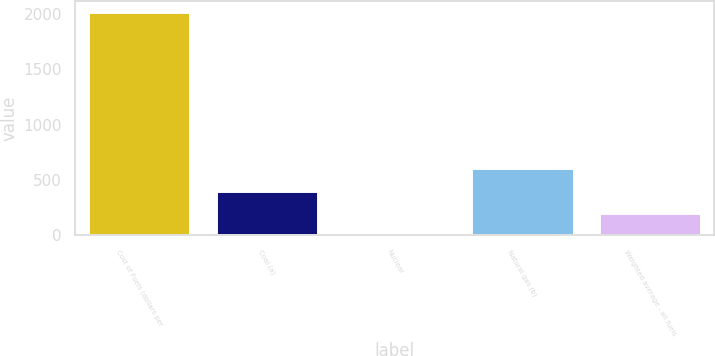Convert chart to OTSL. <chart><loc_0><loc_0><loc_500><loc_500><bar_chart><fcel>Cost of Fuels (dollars per<fcel>Coal (a)<fcel>Nuclear<fcel>Natural gas (b)<fcel>Weighted average - all fuels<nl><fcel>2013<fcel>403.36<fcel>0.94<fcel>604.57<fcel>202.15<nl></chart> 